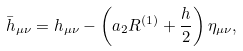Convert formula to latex. <formula><loc_0><loc_0><loc_500><loc_500>\bar { h } _ { \mu \nu } = h _ { \mu \nu } - \left ( a _ { 2 } R ^ { ( 1 ) } + \frac { h } { 2 } \right ) \eta _ { \mu \nu } ,</formula> 